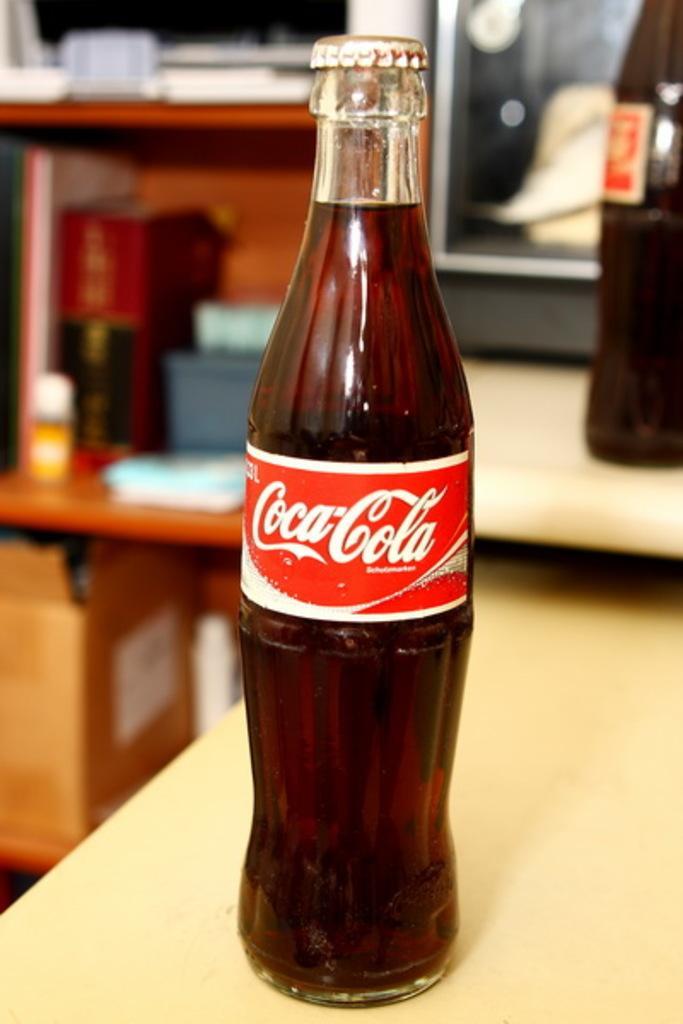Describe this image in one or two sentences. In this image i can see a coca-cola bottle which is on the table. 